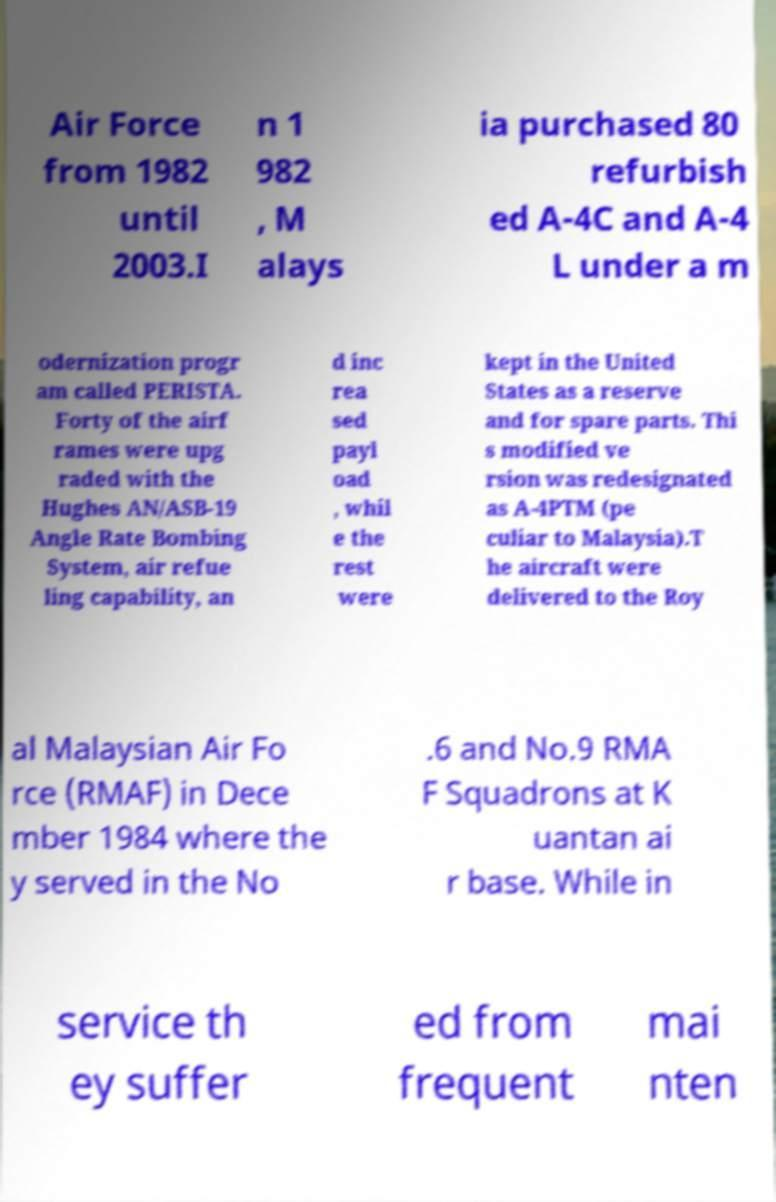Please read and relay the text visible in this image. What does it say? Air Force from 1982 until 2003.I n 1 982 , M alays ia purchased 80 refurbish ed A-4C and A-4 L under a m odernization progr am called PERISTA. Forty of the airf rames were upg raded with the Hughes AN/ASB-19 Angle Rate Bombing System, air refue ling capability, an d inc rea sed payl oad , whil e the rest were kept in the United States as a reserve and for spare parts. Thi s modified ve rsion was redesignated as A-4PTM (pe culiar to Malaysia).T he aircraft were delivered to the Roy al Malaysian Air Fo rce (RMAF) in Dece mber 1984 where the y served in the No .6 and No.9 RMA F Squadrons at K uantan ai r base. While in service th ey suffer ed from frequent mai nten 